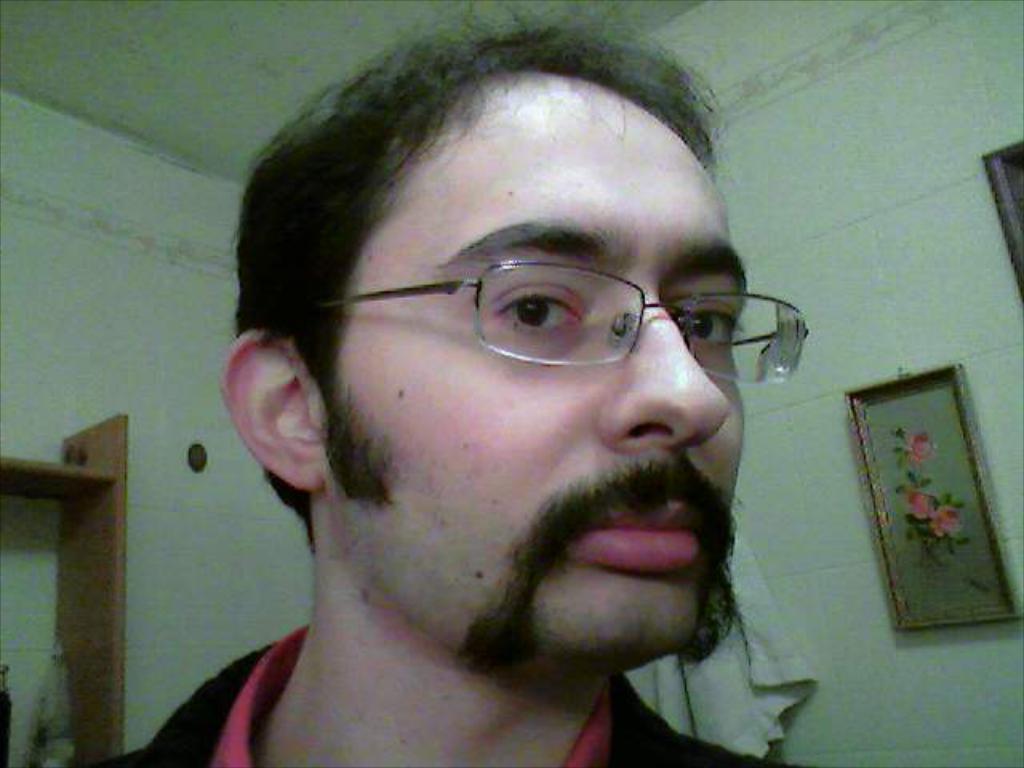How would you summarize this image in a sentence or two? A man is present in a room. There are photo frames on the right and clothes are hanging behind him. There is a shelf on the left. There are white walls. 